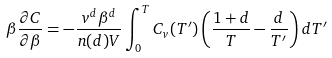<formula> <loc_0><loc_0><loc_500><loc_500>\beta \frac { \partial C } { \partial \beta } = - \frac { v ^ { d } \beta ^ { d } } { n ( d ) V } \int _ { 0 } ^ { T } C _ { v } ( T ^ { \prime } ) \left ( \frac { 1 + d } { T } - \frac { d } { T ^ { \prime } } \right ) d T ^ { \prime }</formula> 